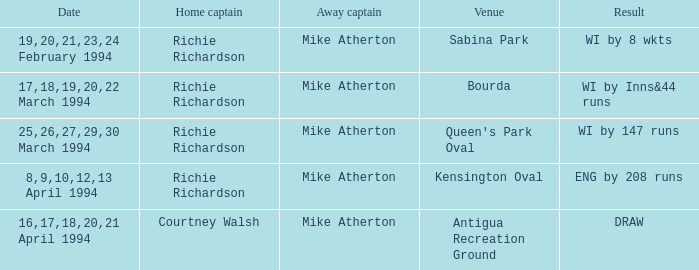What has been achieved by courtney walsh? DRAW. 